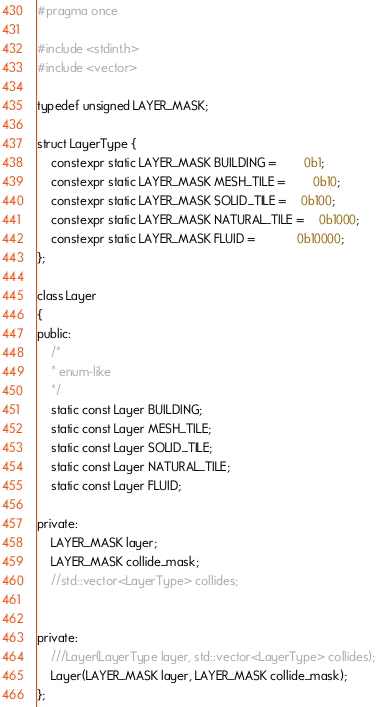Convert code to text. <code><loc_0><loc_0><loc_500><loc_500><_C_>#pragma once

#include <stdint.h>
#include <vector>

typedef unsigned LAYER_MASK;

struct LayerType {
	constexpr static LAYER_MASK BUILDING =		0b1;
	constexpr static LAYER_MASK MESH_TILE =		0b10;
	constexpr static LAYER_MASK SOLID_TILE =	0b100;
	constexpr static LAYER_MASK NATURAL_TILE =	0b1000;
	constexpr static LAYER_MASK FLUID =			0b10000;
};

class Layer
{
public:
	/*
	* enum-like
	*/
	static const Layer BUILDING;
	static const Layer MESH_TILE;
	static const Layer SOLID_TILE;
	static const Layer NATURAL_TILE;
	static const Layer FLUID;

private:
	LAYER_MASK layer;
	LAYER_MASK collide_mask;
	//std::vector<LayerType> collides;


private:
	///Layer(LayerType layer, std::vector<LayerType> collides);
	Layer(LAYER_MASK layer, LAYER_MASK collide_mask);
};

</code> 